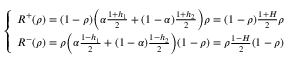Convert formula to latex. <formula><loc_0><loc_0><loc_500><loc_500>\begin{array} { r } { \left \{ \begin{array} { l l } { R ^ { + } ( \rho ) = ( 1 - \rho ) \left ( \alpha \frac { 1 + h _ { 1 } } { 2 } + ( 1 - \alpha ) \frac { 1 + h _ { 2 } } { 2 } \right ) \rho = ( 1 - \rho ) \frac { 1 + H } { 2 } \rho } \\ { R ^ { - } ( \rho ) = \rho \left ( \alpha \frac { 1 - h _ { 1 } } { 2 } + ( 1 - \alpha ) \frac { 1 - h _ { 2 } } { 2 } \right ) ( 1 - \rho ) = \rho \frac { 1 - H } { 2 } ( 1 - \rho ) } \end{array} } \end{array}</formula> 